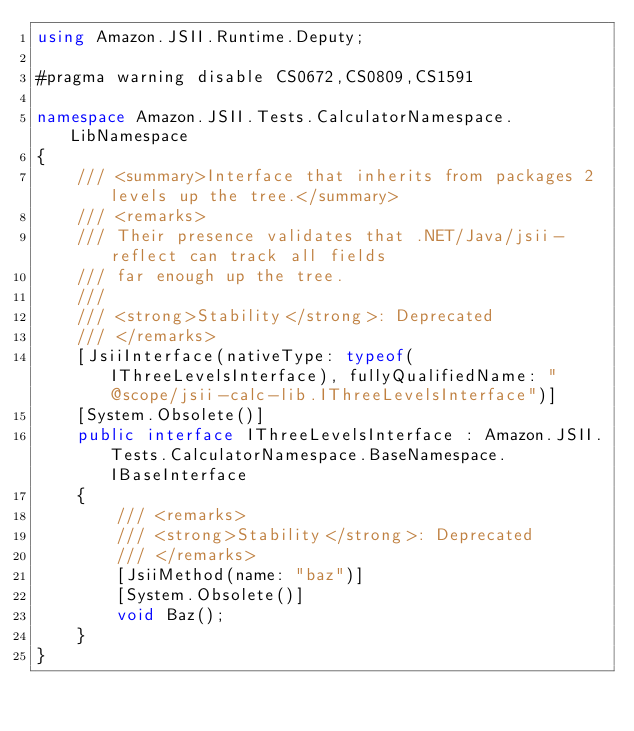<code> <loc_0><loc_0><loc_500><loc_500><_C#_>using Amazon.JSII.Runtime.Deputy;

#pragma warning disable CS0672,CS0809,CS1591

namespace Amazon.JSII.Tests.CalculatorNamespace.LibNamespace
{
    /// <summary>Interface that inherits from packages 2 levels up the tree.</summary>
    /// <remarks>
    /// Their presence validates that .NET/Java/jsii-reflect can track all fields
    /// far enough up the tree.
    /// 
    /// <strong>Stability</strong>: Deprecated
    /// </remarks>
    [JsiiInterface(nativeType: typeof(IThreeLevelsInterface), fullyQualifiedName: "@scope/jsii-calc-lib.IThreeLevelsInterface")]
    [System.Obsolete()]
    public interface IThreeLevelsInterface : Amazon.JSII.Tests.CalculatorNamespace.BaseNamespace.IBaseInterface
    {
        /// <remarks>
        /// <strong>Stability</strong>: Deprecated
        /// </remarks>
        [JsiiMethod(name: "baz")]
        [System.Obsolete()]
        void Baz();
    }
}
</code> 